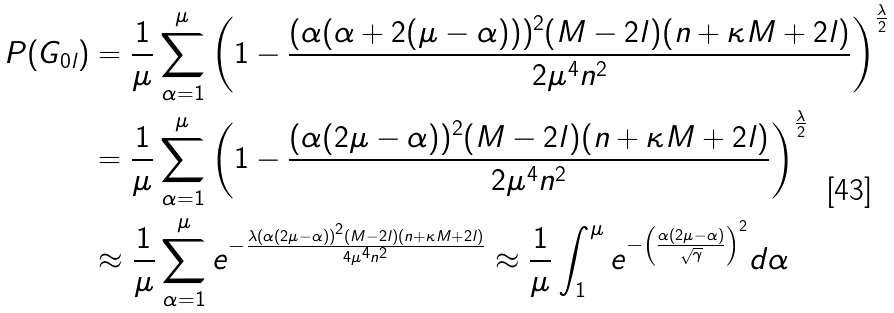Convert formula to latex. <formula><loc_0><loc_0><loc_500><loc_500>P ( G _ { 0 l } ) & = \frac { 1 } { \mu } \sum _ { \alpha = 1 } ^ { \mu } \left ( 1 - \frac { ( \alpha ( \alpha + 2 ( \mu - \alpha ) ) ) ^ { 2 } ( M - 2 l ) ( n + \kappa M + 2 l ) } { 2 \mu ^ { 4 } n ^ { 2 } } \right ) ^ { \frac { \lambda } { 2 } } \\ & = \frac { 1 } { \mu } \sum _ { \alpha = 1 } ^ { \mu } \left ( 1 - \frac { ( \alpha ( 2 \mu - \alpha ) ) ^ { 2 } ( M - 2 l ) ( n + \kappa M + 2 l ) } { 2 \mu ^ { 4 } n ^ { 2 } } \right ) ^ { \frac { \lambda } { 2 } } \\ & \approx \frac { 1 } { \mu } \sum _ { \alpha = 1 } ^ { \mu } e ^ { - \frac { \lambda ( \alpha ( 2 \mu - \alpha ) ) ^ { 2 } ( M - 2 l ) ( n + \kappa M + 2 l ) } { 4 \mu ^ { 4 } n ^ { 2 } } } \approx \frac { 1 } { \mu } \int _ { 1 } ^ { \mu } e ^ { - \left ( \frac { \alpha ( 2 \mu - \alpha ) } { \sqrt { \gamma } } \right ) ^ { 2 } } d \alpha</formula> 